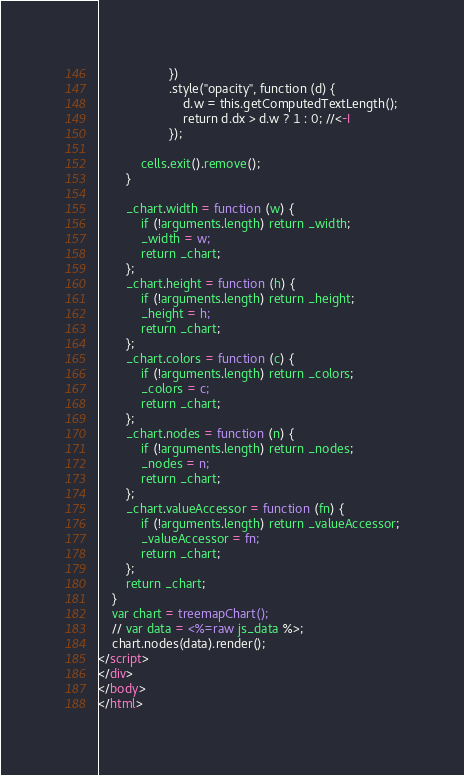Convert code to text. <code><loc_0><loc_0><loc_500><loc_500><_HTML_>                    })
                    .style("opacity", function (d) {
                        d.w = this.getComputedTextLength();
                        return d.dx > d.w ? 1 : 0; //<-I
                    });
                    
            cells.exit().remove();            
        }
        
        _chart.width = function (w) {
            if (!arguments.length) return _width;
            _width = w;
            return _chart;
        };
        _chart.height = function (h) {
            if (!arguments.length) return _height;
            _height = h;
            return _chart;
        };
        _chart.colors = function (c) {
            if (!arguments.length) return _colors;
            _colors = c;
            return _chart;
        };
        _chart.nodes = function (n) {
            if (!arguments.length) return _nodes;
            _nodes = n;
            return _chart;
        };
        _chart.valueAccessor = function (fn) {
            if (!arguments.length) return _valueAccessor;
            _valueAccessor = fn;
            return _chart;
        };
        return _chart;
    }
    var chart = treemapChart();
    // var data = <%=raw js_data %>;
    chart.nodes(data).render();
</script>
</div>
</body>
</html></code> 